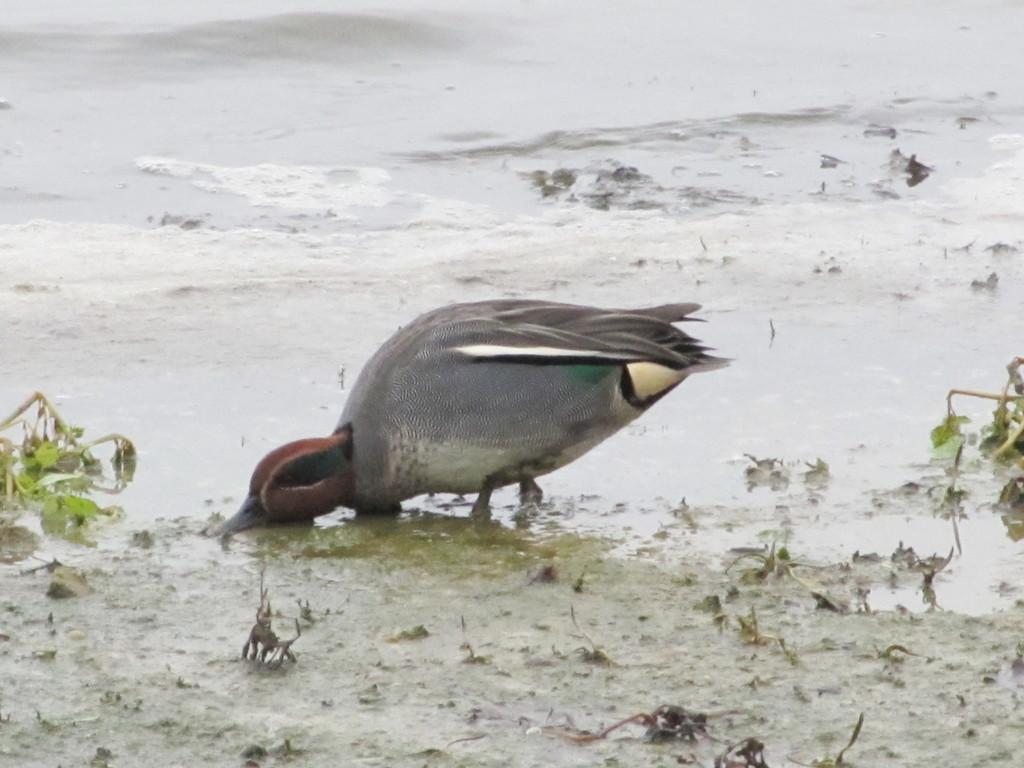What is the main subject in the center of the image? There is a bird in the center of the image. What can be seen in the background of the image? There is water visible in the image. What type of vegetation is present in the image? There are plants in the image. What type of noise can be heard coming from the bird in the image? There is no sound or noise present in the image, as it is a still image. 